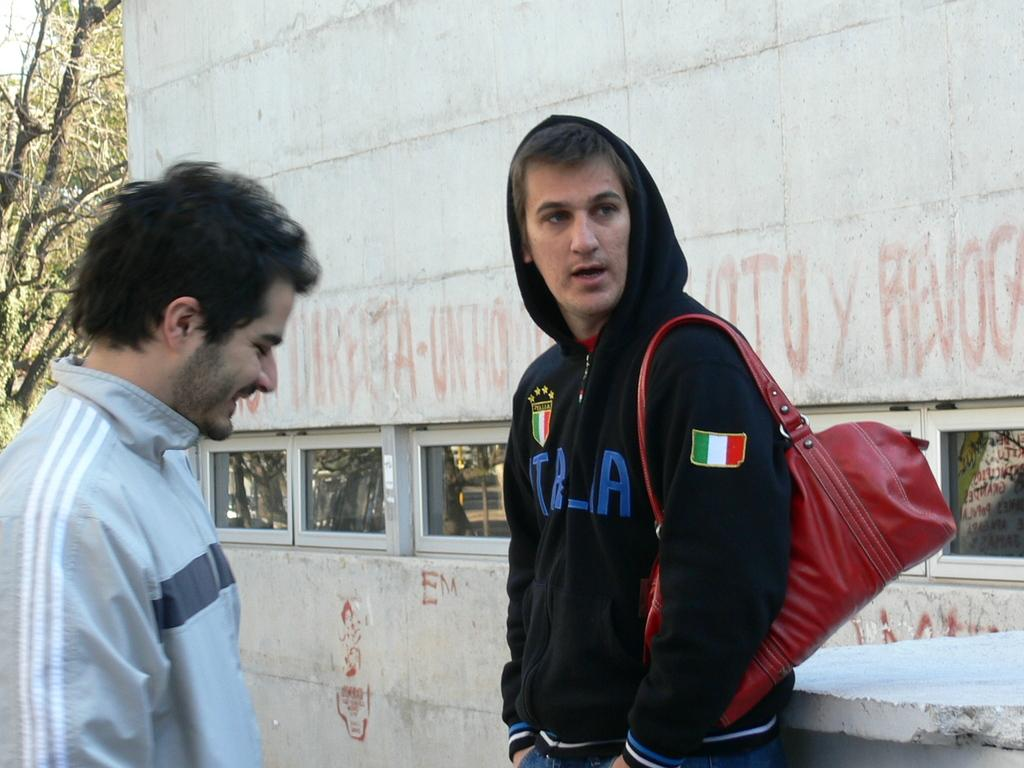<image>
Write a terse but informative summary of the picture. Two men talk in the street, one wears a black hoodie with Italia on the front. 